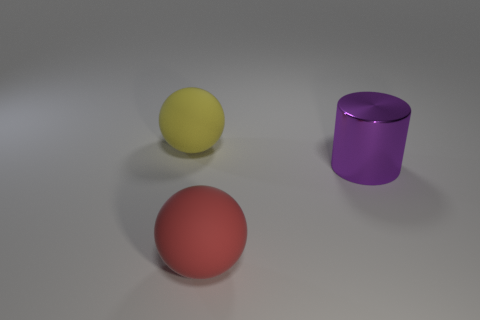Add 1 large shiny cylinders. How many objects exist? 4 Subtract all cylinders. How many objects are left? 2 Subtract all big red spheres. Subtract all purple cylinders. How many objects are left? 1 Add 3 large purple cylinders. How many large purple cylinders are left? 4 Add 1 large cylinders. How many large cylinders exist? 2 Subtract 0 cyan spheres. How many objects are left? 3 